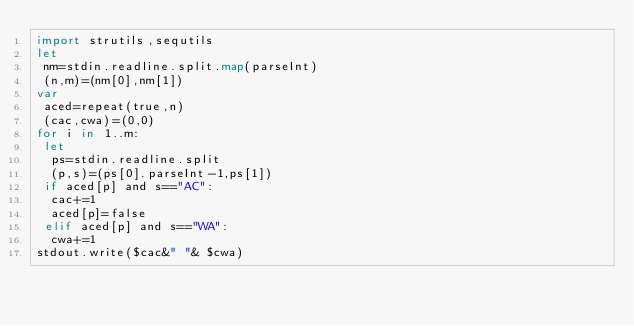Convert code to text. <code><loc_0><loc_0><loc_500><loc_500><_Nim_>import strutils,sequtils
let
 nm=stdin.readline.split.map(parseInt)
 (n,m)=(nm[0],nm[1])
var
 aced=repeat(true,n)
 (cac,cwa)=(0,0)
for i in 1..m:
 let
  ps=stdin.readline.split
  (p,s)=(ps[0].parseInt-1,ps[1])
 if aced[p] and s=="AC":
  cac+=1
  aced[p]=false
 elif aced[p] and s=="WA":
  cwa+=1
stdout.write($cac&" "& $cwa)</code> 